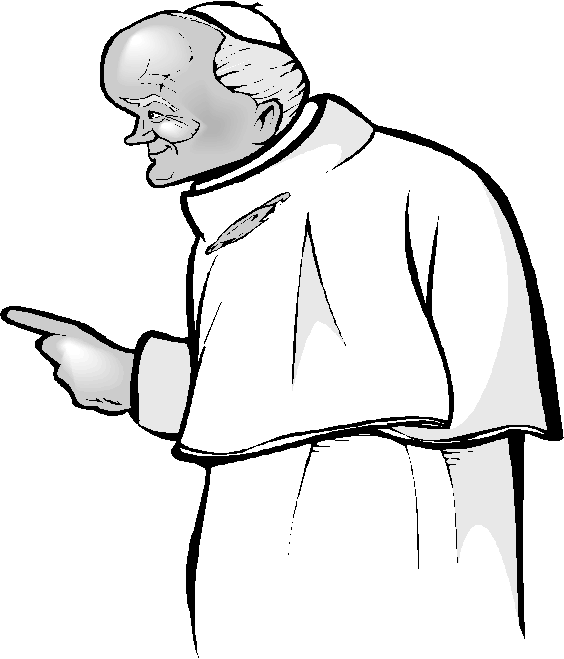How does the figure's posture and facial expression contribute to the overall perception of his character? The figure's upright posture and the gesture of his raised, pointing right hand convey a sense of authority and intention, often associated with roles such as teaching, leadership, or making a proclamation. His facial expression, characterized by wrinkles and a focused gaze, implies wisdom, experience, and determination. These elements together create the impression of a knowledgeable and perhaps demanding authority figure, commanding respect and attention, likely within a religious, educational, or formal context. 